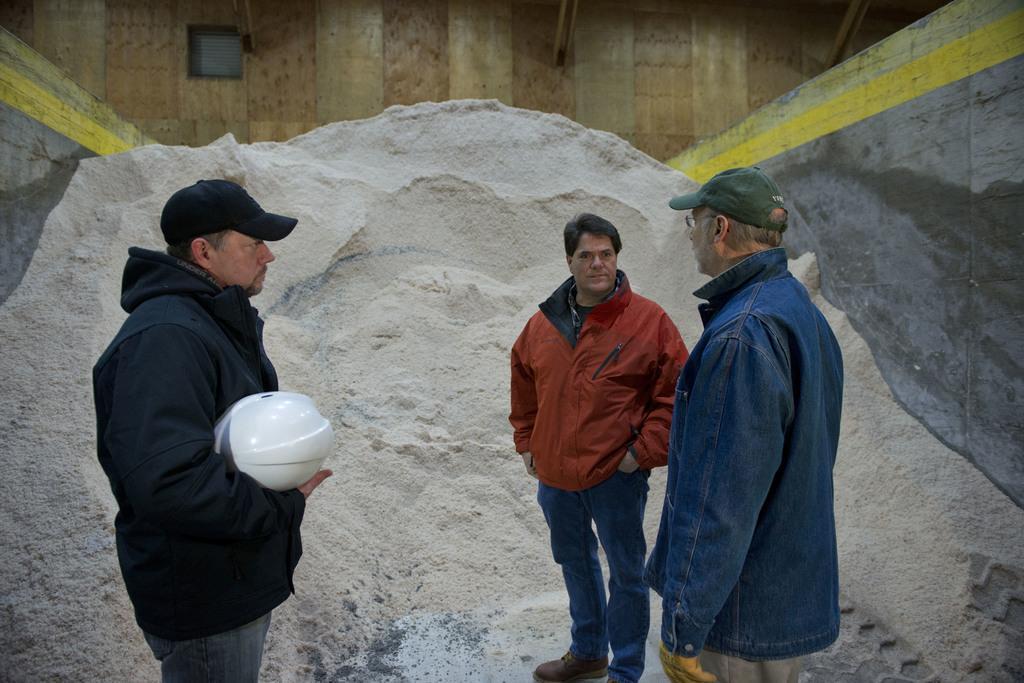Could you give a brief overview of what you see in this image? In this image we can see three persons. Here we can see two persons on the right side. They are wearing jackets. Here we can see a cap on his head. Here we can see a man on the left side. He is wearing a jacket and he is holding a hard hat in his left hand. In the background, we can see the sand. 